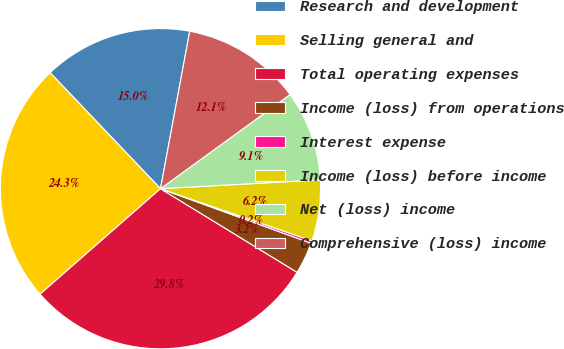Convert chart. <chart><loc_0><loc_0><loc_500><loc_500><pie_chart><fcel>Research and development<fcel>Selling general and<fcel>Total operating expenses<fcel>Income (loss) from operations<fcel>Interest expense<fcel>Income (loss) before income<fcel>Net (loss) income<fcel>Comprehensive (loss) income<nl><fcel>15.03%<fcel>24.34%<fcel>29.81%<fcel>3.21%<fcel>0.25%<fcel>6.16%<fcel>9.12%<fcel>12.08%<nl></chart> 